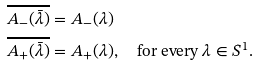Convert formula to latex. <formula><loc_0><loc_0><loc_500><loc_500>\overline { A _ { - } ( \bar { \lambda } ) } & = A _ { - } ( \lambda ) \\ \overline { A _ { + } ( \bar { \lambda } ) } & = A _ { + } ( \lambda ) , \quad \text {for every } \lambda \in S ^ { 1 } .</formula> 